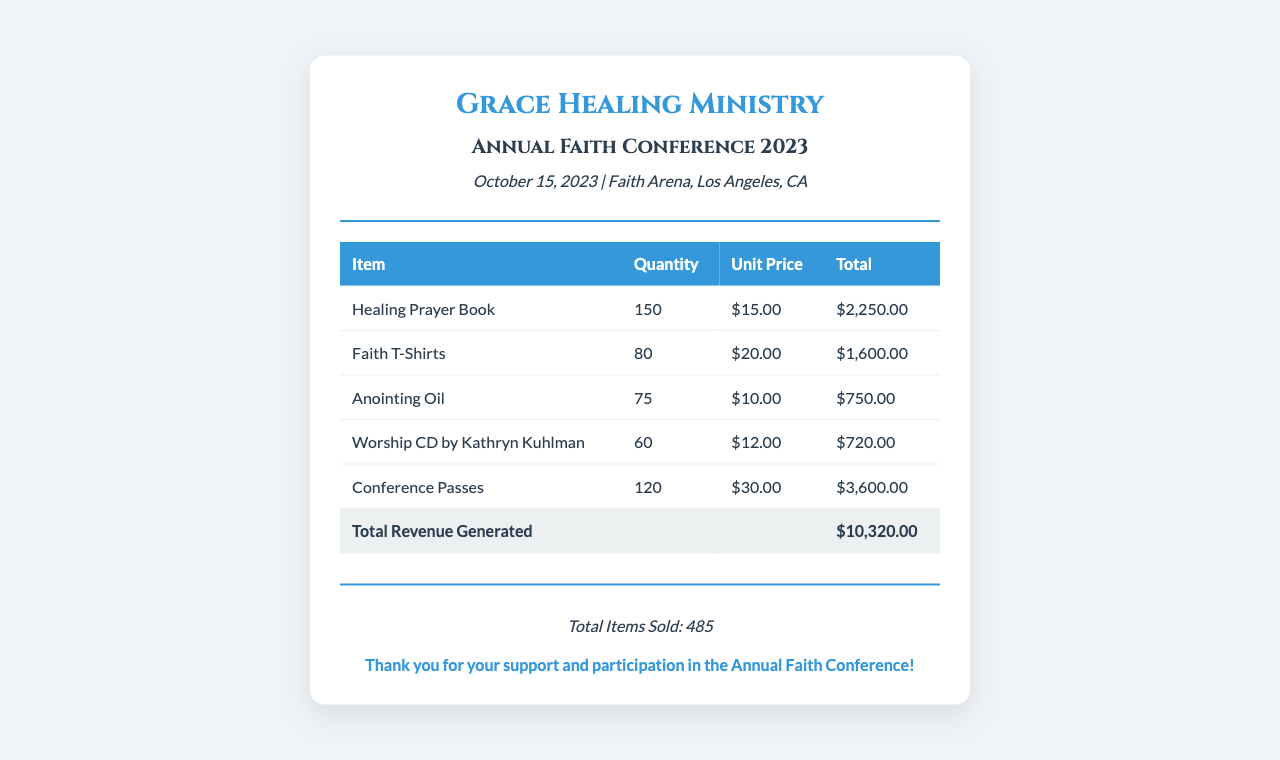what is the total revenue generated? The total revenue generated is listed at the bottom of the table in the document as the sum of all individual item totals.
Answer: $10,320.00 how many Healing Prayer Books were sold? The quantity of Healing Prayer Books sold is stated in the row corresponding to that item in the table.
Answer: 150 what was the unit price of Faith T-Shirts? The unit price for Faith T-Shirts is mentioned in the respective table row.
Answer: $20.00 how many items were sold in total? The total number of items sold is provided in the summary section at the bottom of the receipt.
Answer: 485 what was the total income from Conference Passes? The total income from Conference Passes can be calculated by multiplying the quantity sold with the unit price. This total is also found in the document table.
Answer: $3,600.00 what is the date of the Annual Faith Conference? The date of the event is specified in the event details section at the top of the document.
Answer: October 15, 2023 who is featured in the Worship CD? The name of the individual featured in the Worship CD is stated alongside the item in the table.
Answer: Kathryn Kuhlman what is the total quantity of Anointing Oil sold? The quantity of Anointing Oil sold is mentioned in the corresponding table row.
Answer: 75 what is the venue of the conference? The venue of the conference is provided in the event details section along with the date.
Answer: Faith Arena, Los Angeles, CA 